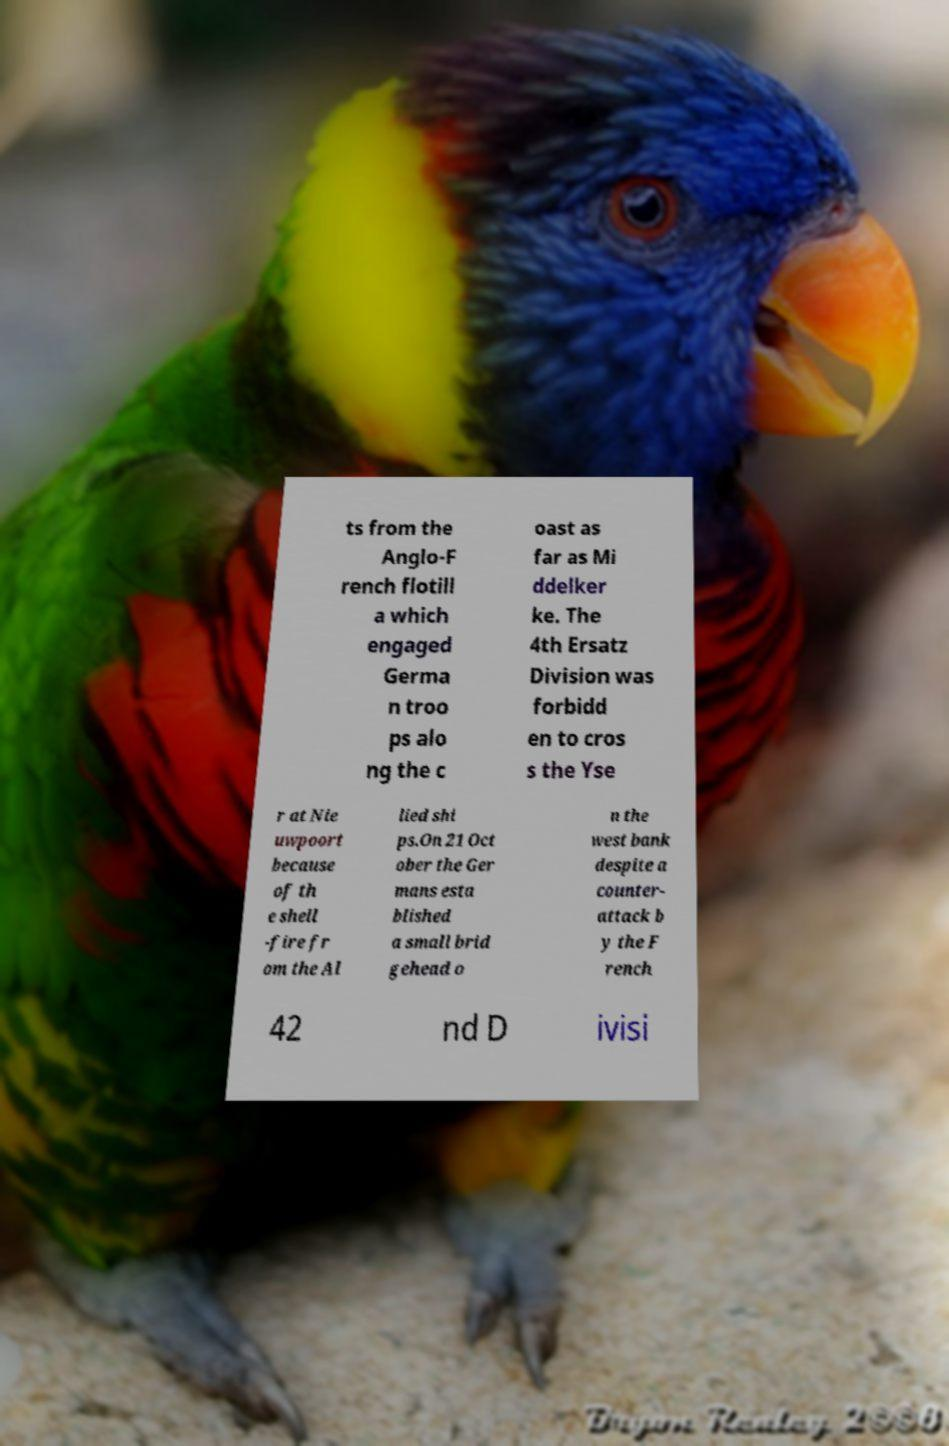Can you accurately transcribe the text from the provided image for me? ts from the Anglo-F rench flotill a which engaged Germa n troo ps alo ng the c oast as far as Mi ddelker ke. The 4th Ersatz Division was forbidd en to cros s the Yse r at Nie uwpoort because of th e shell -fire fr om the Al lied shi ps.On 21 Oct ober the Ger mans esta blished a small brid gehead o n the west bank despite a counter- attack b y the F rench 42 nd D ivisi 